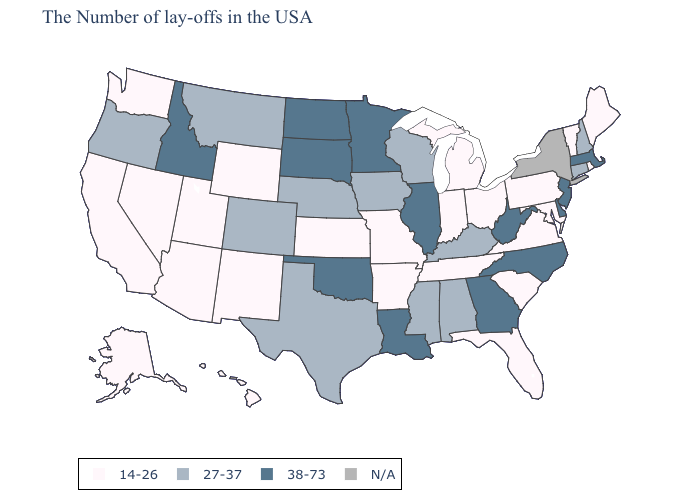Which states have the lowest value in the USA?
Give a very brief answer. Maine, Rhode Island, Vermont, Maryland, Pennsylvania, Virginia, South Carolina, Ohio, Florida, Michigan, Indiana, Tennessee, Missouri, Arkansas, Kansas, Wyoming, New Mexico, Utah, Arizona, Nevada, California, Washington, Alaska, Hawaii. Does Illinois have the lowest value in the USA?
Answer briefly. No. Name the states that have a value in the range N/A?
Concise answer only. New York. What is the value of Florida?
Answer briefly. 14-26. What is the value of Wisconsin?
Concise answer only. 27-37. What is the value of Washington?
Keep it brief. 14-26. What is the lowest value in states that border Minnesota?
Be succinct. 27-37. Name the states that have a value in the range N/A?
Be succinct. New York. Which states hav the highest value in the West?
Give a very brief answer. Idaho. Among the states that border Maine , which have the highest value?
Keep it brief. New Hampshire. Name the states that have a value in the range 38-73?
Quick response, please. Massachusetts, New Jersey, Delaware, North Carolina, West Virginia, Georgia, Illinois, Louisiana, Minnesota, Oklahoma, South Dakota, North Dakota, Idaho. Name the states that have a value in the range 27-37?
Concise answer only. New Hampshire, Connecticut, Kentucky, Alabama, Wisconsin, Mississippi, Iowa, Nebraska, Texas, Colorado, Montana, Oregon. Does the map have missing data?
Answer briefly. Yes. 